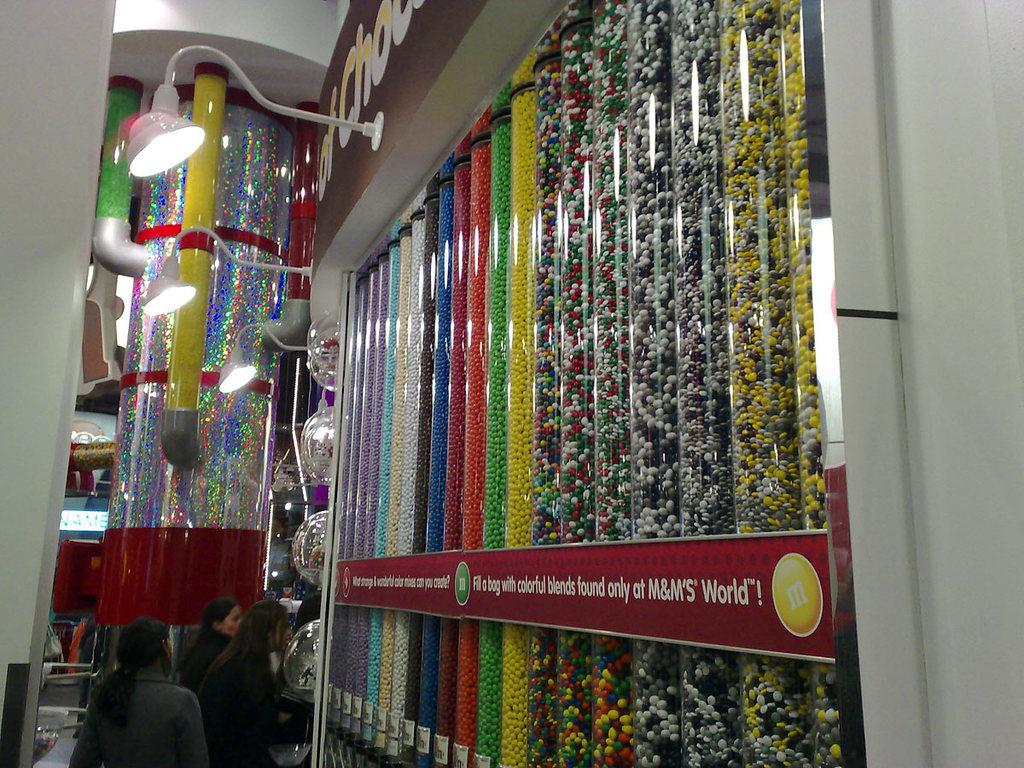<image>
Create a compact narrative representing the image presented. A sign in a store invites people to fill a bag with M&M's. 